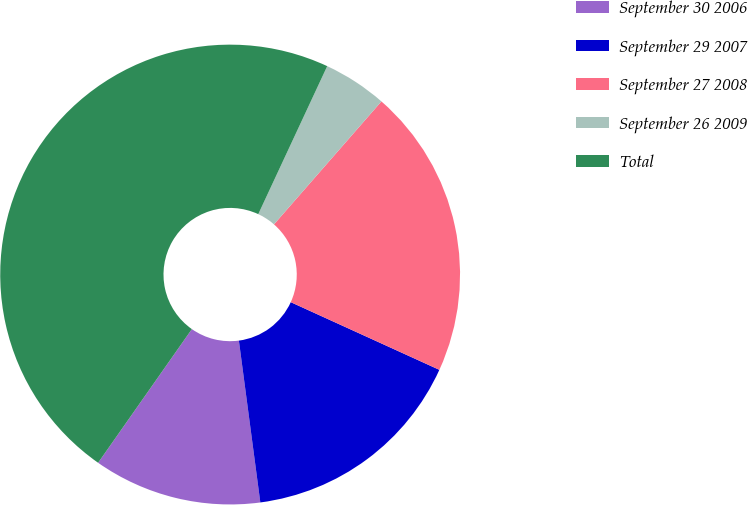Convert chart to OTSL. <chart><loc_0><loc_0><loc_500><loc_500><pie_chart><fcel>September 30 2006<fcel>September 29 2007<fcel>September 27 2008<fcel>September 26 2009<fcel>Total<nl><fcel>11.83%<fcel>16.1%<fcel>20.37%<fcel>4.49%<fcel>47.2%<nl></chart> 